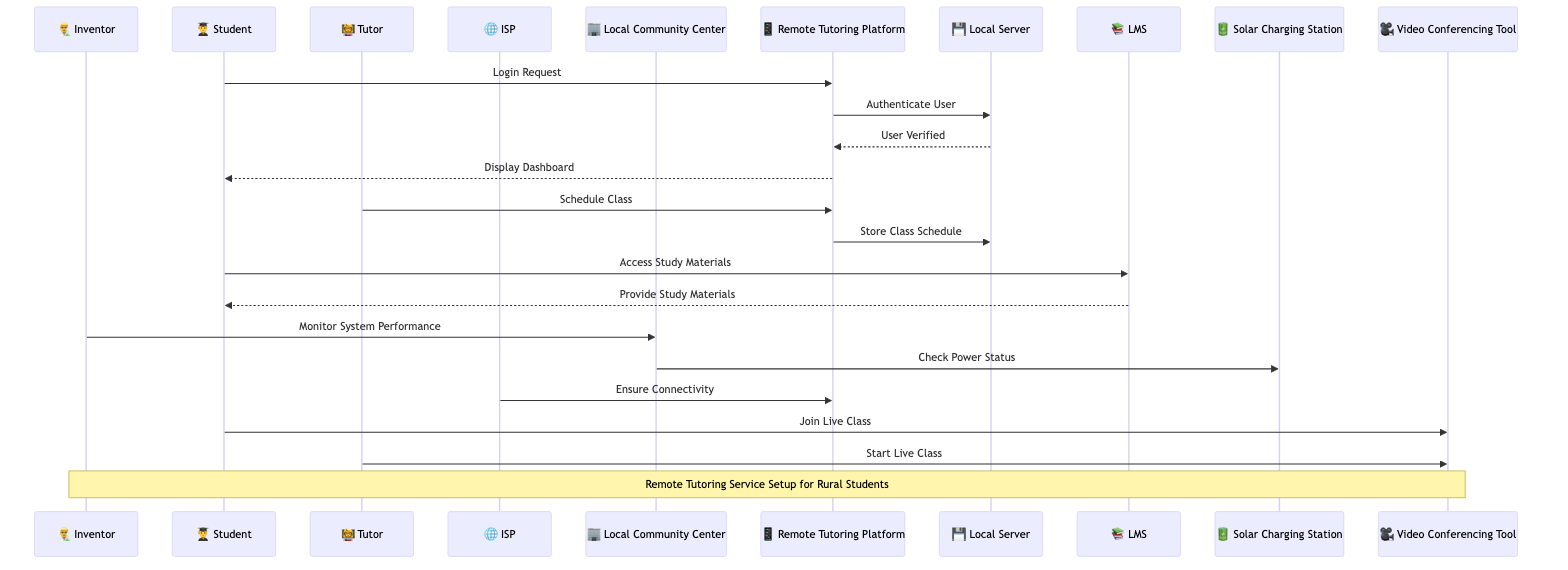What is the role of the Inventor in the diagram? The Inventor is depicted as a System Designer/Administrator, responsible for overseeing the overall performance of the remote tutoring service.
Answer: System Designer/Administrator How many actors are present in the diagram? By counting the unique actors listed, we see there are five actors: Inventor, Student, Tutor, Internet Service Provider, and Local Community Center.
Answer: Five What is the first message sent in the sequence? The first message in the sequence is a Login Request sent from the Student to the Remote Tutoring Platform.
Answer: Login Request Which actor checks the power status of the infrastructure? The Local Community Center checks the power status to ensure the Solar Charging Station operates effectively for the service.
Answer: Local Community Center What does the Student access after logging in? After logging in, the Student accesses the Learning Management System to find study materials for their classes.
Answer: Study Materials Who ensures connectivity for the Remote Tutoring Platform? The Internet Service Provider is responsible for ensuring connectivity, as indicated in the sequence diagram.
Answer: Internet Service Provider What action does the Tutor take after class scheduling? After scheduling a class, the Tutor starts the live class session using the Video Conferencing Tool.
Answer: Start Live Class How many software objects are part of the setup? The diagram includes three software objects: Remote Tutoring Platform, Video Conferencing Tool, and Learning Management System.
Answer: Three What does the Local Community Center do upon communication with the Inventor? Upon communication with the Inventor, the Local Community Center monitors the performance of the remote tutoring system as part of their support role.
Answer: Monitor System Performance Which tool does the Student use to join the live class? The Student joins the live class using the Video Conferencing Tool, which facilitates the online learning experience.
Answer: Video Conferencing Tool 